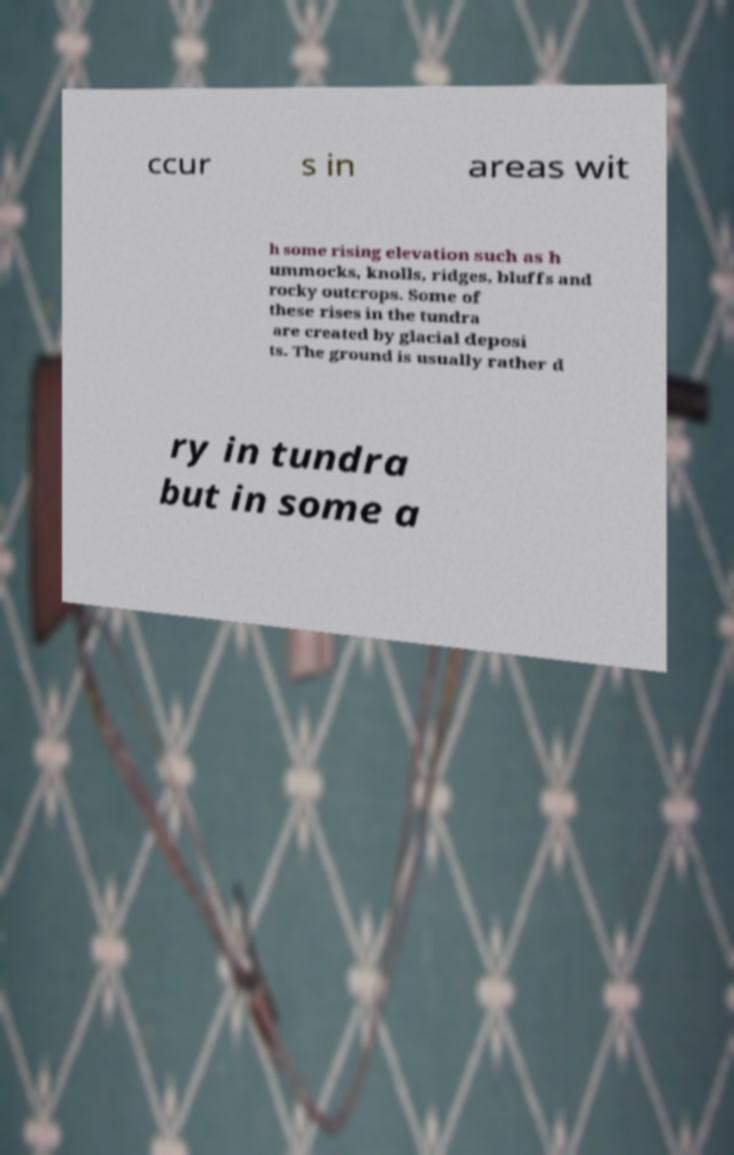Please identify and transcribe the text found in this image. ccur s in areas wit h some rising elevation such as h ummocks, knolls, ridges, bluffs and rocky outcrops. Some of these rises in the tundra are created by glacial deposi ts. The ground is usually rather d ry in tundra but in some a 